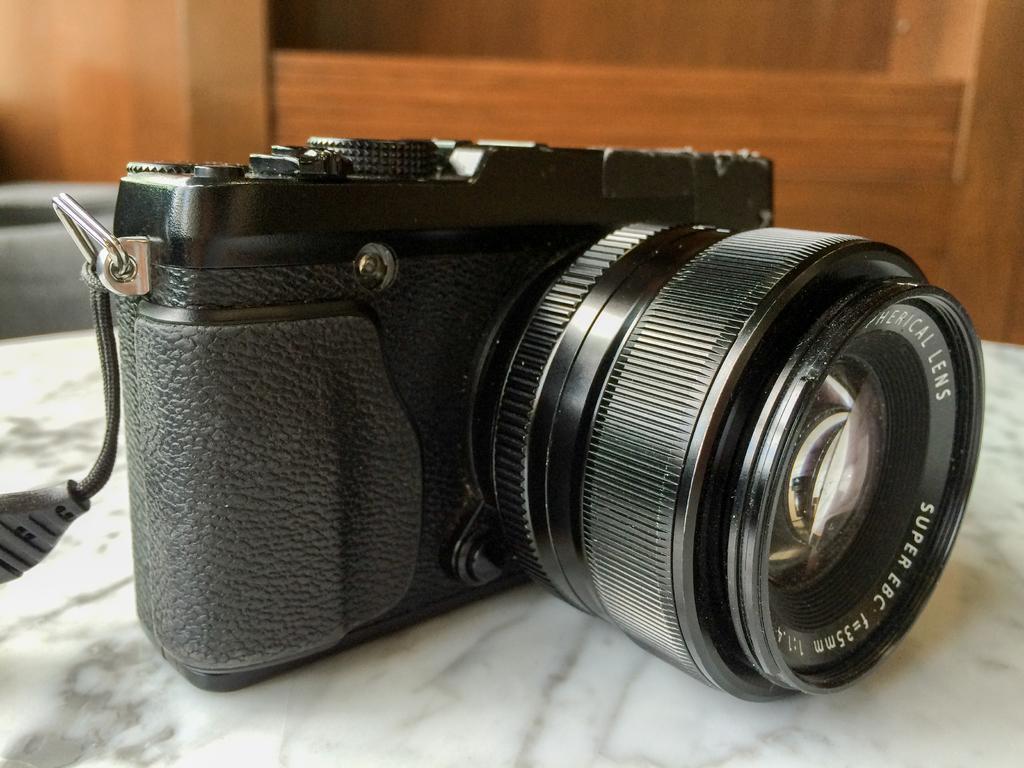How would you summarize this image in a sentence or two? In the image there is a camera on the white surface. Behind the camera there is a wooden object. 